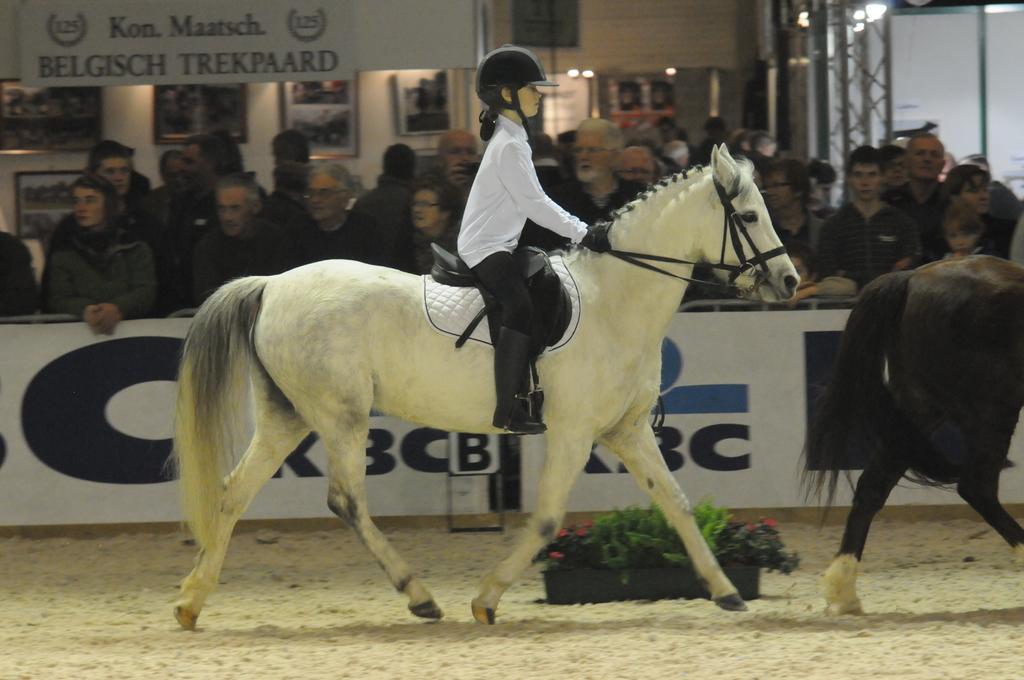Describe this image in one or two sentences. there is a small girl riding a horse and there are so many people watching it and there is a flower pot on the ground. 